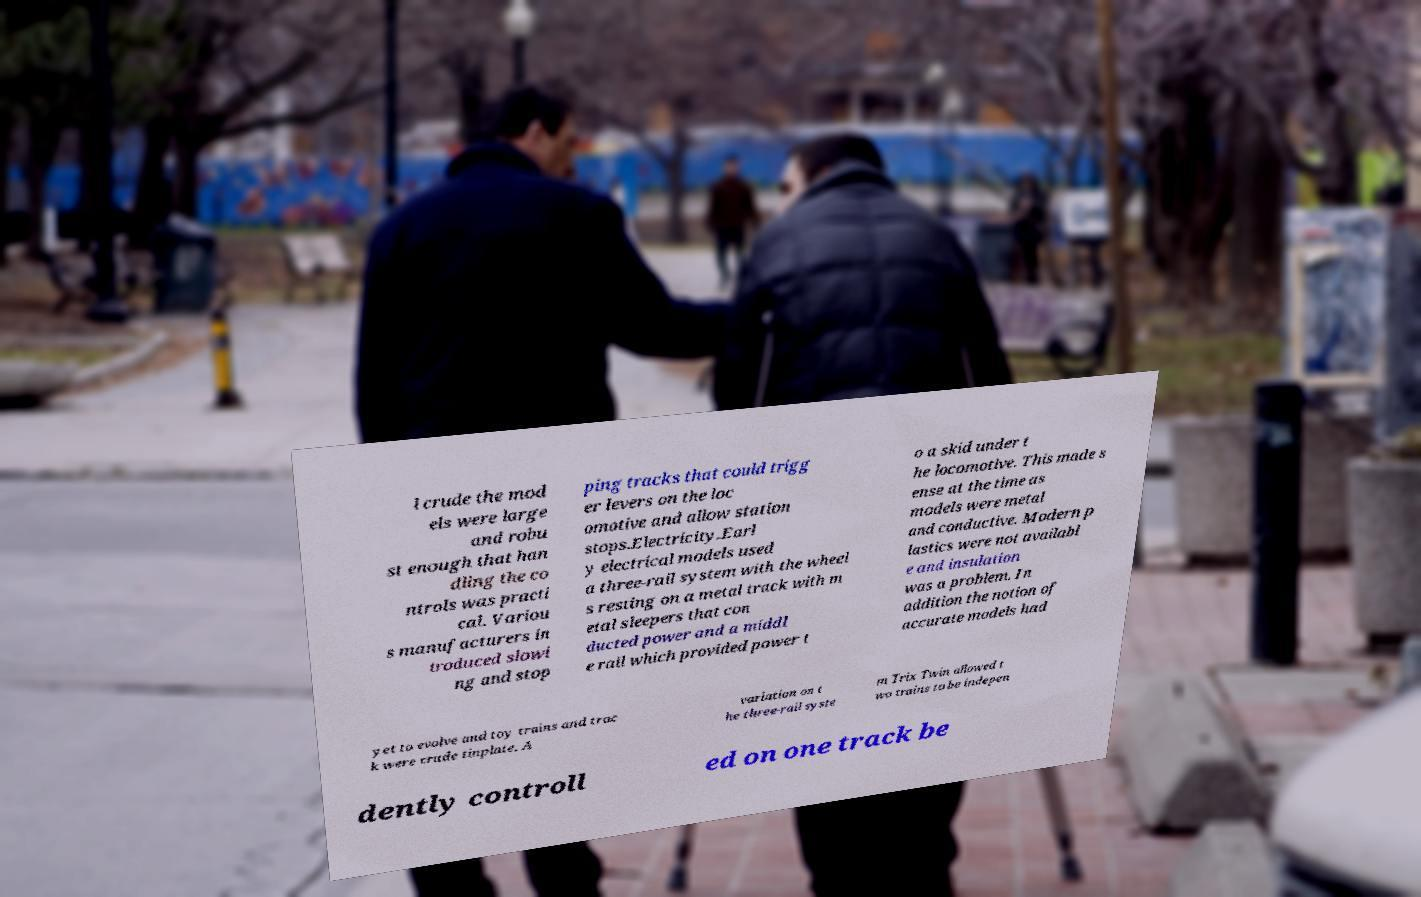Could you extract and type out the text from this image? l crude the mod els were large and robu st enough that han dling the co ntrols was practi cal. Variou s manufacturers in troduced slowi ng and stop ping tracks that could trigg er levers on the loc omotive and allow station stops.Electricity.Earl y electrical models used a three-rail system with the wheel s resting on a metal track with m etal sleepers that con ducted power and a middl e rail which provided power t o a skid under t he locomotive. This made s ense at the time as models were metal and conductive. Modern p lastics were not availabl e and insulation was a problem. In addition the notion of accurate models had yet to evolve and toy trains and trac k were crude tinplate. A variation on t he three-rail syste m Trix Twin allowed t wo trains to be indepen dently controll ed on one track be 